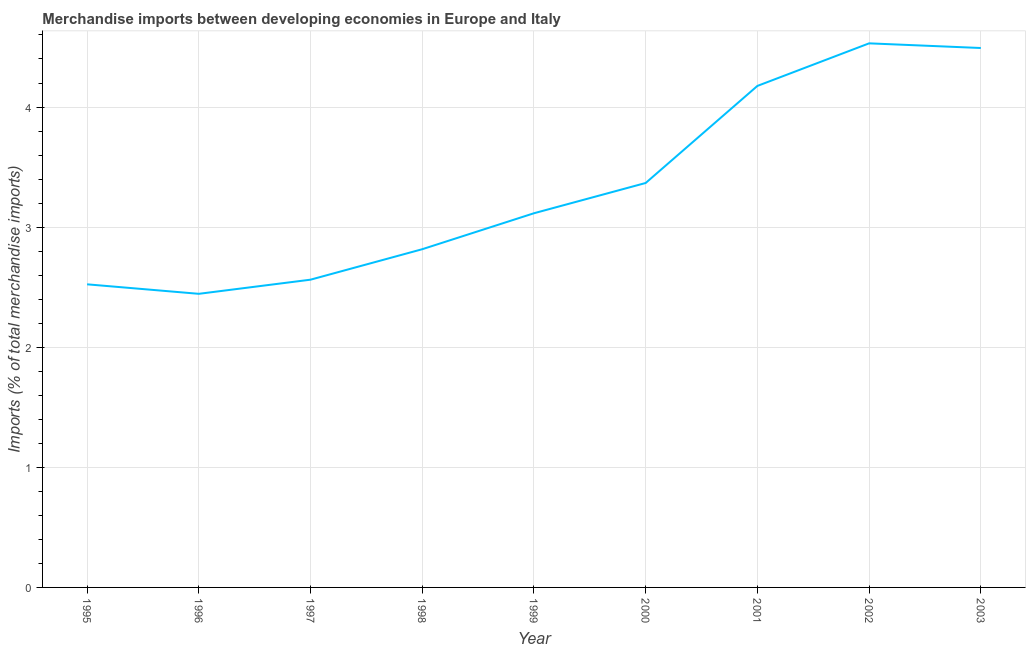What is the merchandise imports in 1995?
Keep it short and to the point. 2.52. Across all years, what is the maximum merchandise imports?
Your answer should be very brief. 4.53. Across all years, what is the minimum merchandise imports?
Your answer should be very brief. 2.44. What is the sum of the merchandise imports?
Your answer should be very brief. 30.03. What is the difference between the merchandise imports in 1999 and 2002?
Your answer should be very brief. -1.41. What is the average merchandise imports per year?
Provide a short and direct response. 3.34. What is the median merchandise imports?
Give a very brief answer. 3.12. Do a majority of the years between 1998 and 2000 (inclusive) have merchandise imports greater than 3.2 %?
Give a very brief answer. No. What is the ratio of the merchandise imports in 1997 to that in 2002?
Your response must be concise. 0.57. Is the merchandise imports in 1998 less than that in 2002?
Provide a succinct answer. Yes. What is the difference between the highest and the second highest merchandise imports?
Provide a short and direct response. 0.04. Is the sum of the merchandise imports in 1996 and 2003 greater than the maximum merchandise imports across all years?
Offer a very short reply. Yes. What is the difference between the highest and the lowest merchandise imports?
Your answer should be compact. 2.09. Does the merchandise imports monotonically increase over the years?
Your answer should be very brief. No. How many years are there in the graph?
Give a very brief answer. 9. What is the difference between two consecutive major ticks on the Y-axis?
Your answer should be very brief. 1. Are the values on the major ticks of Y-axis written in scientific E-notation?
Give a very brief answer. No. What is the title of the graph?
Make the answer very short. Merchandise imports between developing economies in Europe and Italy. What is the label or title of the Y-axis?
Make the answer very short. Imports (% of total merchandise imports). What is the Imports (% of total merchandise imports) of 1995?
Ensure brevity in your answer.  2.52. What is the Imports (% of total merchandise imports) in 1996?
Make the answer very short. 2.44. What is the Imports (% of total merchandise imports) in 1997?
Provide a short and direct response. 2.56. What is the Imports (% of total merchandise imports) in 1998?
Make the answer very short. 2.82. What is the Imports (% of total merchandise imports) of 1999?
Keep it short and to the point. 3.12. What is the Imports (% of total merchandise imports) in 2000?
Give a very brief answer. 3.37. What is the Imports (% of total merchandise imports) in 2001?
Provide a short and direct response. 4.18. What is the Imports (% of total merchandise imports) of 2002?
Give a very brief answer. 4.53. What is the Imports (% of total merchandise imports) in 2003?
Offer a terse response. 4.49. What is the difference between the Imports (% of total merchandise imports) in 1995 and 1996?
Ensure brevity in your answer.  0.08. What is the difference between the Imports (% of total merchandise imports) in 1995 and 1997?
Offer a terse response. -0.04. What is the difference between the Imports (% of total merchandise imports) in 1995 and 1998?
Keep it short and to the point. -0.29. What is the difference between the Imports (% of total merchandise imports) in 1995 and 1999?
Your response must be concise. -0.59. What is the difference between the Imports (% of total merchandise imports) in 1995 and 2000?
Keep it short and to the point. -0.84. What is the difference between the Imports (% of total merchandise imports) in 1995 and 2001?
Your answer should be very brief. -1.65. What is the difference between the Imports (% of total merchandise imports) in 1995 and 2002?
Make the answer very short. -2.01. What is the difference between the Imports (% of total merchandise imports) in 1995 and 2003?
Make the answer very short. -1.97. What is the difference between the Imports (% of total merchandise imports) in 1996 and 1997?
Your answer should be very brief. -0.12. What is the difference between the Imports (% of total merchandise imports) in 1996 and 1998?
Keep it short and to the point. -0.37. What is the difference between the Imports (% of total merchandise imports) in 1996 and 1999?
Offer a terse response. -0.67. What is the difference between the Imports (% of total merchandise imports) in 1996 and 2000?
Provide a succinct answer. -0.92. What is the difference between the Imports (% of total merchandise imports) in 1996 and 2001?
Give a very brief answer. -1.73. What is the difference between the Imports (% of total merchandise imports) in 1996 and 2002?
Provide a short and direct response. -2.09. What is the difference between the Imports (% of total merchandise imports) in 1996 and 2003?
Offer a terse response. -2.05. What is the difference between the Imports (% of total merchandise imports) in 1997 and 1998?
Keep it short and to the point. -0.25. What is the difference between the Imports (% of total merchandise imports) in 1997 and 1999?
Give a very brief answer. -0.55. What is the difference between the Imports (% of total merchandise imports) in 1997 and 2000?
Ensure brevity in your answer.  -0.81. What is the difference between the Imports (% of total merchandise imports) in 1997 and 2001?
Offer a very short reply. -1.61. What is the difference between the Imports (% of total merchandise imports) in 1997 and 2002?
Make the answer very short. -1.97. What is the difference between the Imports (% of total merchandise imports) in 1997 and 2003?
Give a very brief answer. -1.93. What is the difference between the Imports (% of total merchandise imports) in 1998 and 1999?
Offer a terse response. -0.3. What is the difference between the Imports (% of total merchandise imports) in 1998 and 2000?
Ensure brevity in your answer.  -0.55. What is the difference between the Imports (% of total merchandise imports) in 1998 and 2001?
Make the answer very short. -1.36. What is the difference between the Imports (% of total merchandise imports) in 1998 and 2002?
Make the answer very short. -1.71. What is the difference between the Imports (% of total merchandise imports) in 1998 and 2003?
Ensure brevity in your answer.  -1.68. What is the difference between the Imports (% of total merchandise imports) in 1999 and 2000?
Your response must be concise. -0.25. What is the difference between the Imports (% of total merchandise imports) in 1999 and 2001?
Keep it short and to the point. -1.06. What is the difference between the Imports (% of total merchandise imports) in 1999 and 2002?
Provide a succinct answer. -1.41. What is the difference between the Imports (% of total merchandise imports) in 1999 and 2003?
Your answer should be very brief. -1.38. What is the difference between the Imports (% of total merchandise imports) in 2000 and 2001?
Provide a succinct answer. -0.81. What is the difference between the Imports (% of total merchandise imports) in 2000 and 2002?
Provide a succinct answer. -1.16. What is the difference between the Imports (% of total merchandise imports) in 2000 and 2003?
Offer a terse response. -1.12. What is the difference between the Imports (% of total merchandise imports) in 2001 and 2002?
Keep it short and to the point. -0.35. What is the difference between the Imports (% of total merchandise imports) in 2001 and 2003?
Your answer should be compact. -0.32. What is the difference between the Imports (% of total merchandise imports) in 2002 and 2003?
Keep it short and to the point. 0.04. What is the ratio of the Imports (% of total merchandise imports) in 1995 to that in 1996?
Make the answer very short. 1.03. What is the ratio of the Imports (% of total merchandise imports) in 1995 to that in 1997?
Ensure brevity in your answer.  0.98. What is the ratio of the Imports (% of total merchandise imports) in 1995 to that in 1998?
Keep it short and to the point. 0.9. What is the ratio of the Imports (% of total merchandise imports) in 1995 to that in 1999?
Your response must be concise. 0.81. What is the ratio of the Imports (% of total merchandise imports) in 1995 to that in 2000?
Your response must be concise. 0.75. What is the ratio of the Imports (% of total merchandise imports) in 1995 to that in 2001?
Provide a succinct answer. 0.6. What is the ratio of the Imports (% of total merchandise imports) in 1995 to that in 2002?
Your response must be concise. 0.56. What is the ratio of the Imports (% of total merchandise imports) in 1995 to that in 2003?
Your answer should be compact. 0.56. What is the ratio of the Imports (% of total merchandise imports) in 1996 to that in 1997?
Ensure brevity in your answer.  0.95. What is the ratio of the Imports (% of total merchandise imports) in 1996 to that in 1998?
Make the answer very short. 0.87. What is the ratio of the Imports (% of total merchandise imports) in 1996 to that in 1999?
Ensure brevity in your answer.  0.79. What is the ratio of the Imports (% of total merchandise imports) in 1996 to that in 2000?
Give a very brief answer. 0.73. What is the ratio of the Imports (% of total merchandise imports) in 1996 to that in 2001?
Offer a terse response. 0.58. What is the ratio of the Imports (% of total merchandise imports) in 1996 to that in 2002?
Offer a very short reply. 0.54. What is the ratio of the Imports (% of total merchandise imports) in 1996 to that in 2003?
Offer a terse response. 0.54. What is the ratio of the Imports (% of total merchandise imports) in 1997 to that in 1998?
Your answer should be compact. 0.91. What is the ratio of the Imports (% of total merchandise imports) in 1997 to that in 1999?
Keep it short and to the point. 0.82. What is the ratio of the Imports (% of total merchandise imports) in 1997 to that in 2000?
Give a very brief answer. 0.76. What is the ratio of the Imports (% of total merchandise imports) in 1997 to that in 2001?
Ensure brevity in your answer.  0.61. What is the ratio of the Imports (% of total merchandise imports) in 1997 to that in 2002?
Keep it short and to the point. 0.57. What is the ratio of the Imports (% of total merchandise imports) in 1997 to that in 2003?
Give a very brief answer. 0.57. What is the ratio of the Imports (% of total merchandise imports) in 1998 to that in 1999?
Your response must be concise. 0.9. What is the ratio of the Imports (% of total merchandise imports) in 1998 to that in 2000?
Your answer should be compact. 0.84. What is the ratio of the Imports (% of total merchandise imports) in 1998 to that in 2001?
Keep it short and to the point. 0.67. What is the ratio of the Imports (% of total merchandise imports) in 1998 to that in 2002?
Your response must be concise. 0.62. What is the ratio of the Imports (% of total merchandise imports) in 1998 to that in 2003?
Give a very brief answer. 0.63. What is the ratio of the Imports (% of total merchandise imports) in 1999 to that in 2000?
Provide a short and direct response. 0.93. What is the ratio of the Imports (% of total merchandise imports) in 1999 to that in 2001?
Your response must be concise. 0.75. What is the ratio of the Imports (% of total merchandise imports) in 1999 to that in 2002?
Offer a very short reply. 0.69. What is the ratio of the Imports (% of total merchandise imports) in 1999 to that in 2003?
Offer a terse response. 0.69. What is the ratio of the Imports (% of total merchandise imports) in 2000 to that in 2001?
Keep it short and to the point. 0.81. What is the ratio of the Imports (% of total merchandise imports) in 2000 to that in 2002?
Keep it short and to the point. 0.74. What is the ratio of the Imports (% of total merchandise imports) in 2001 to that in 2002?
Offer a very short reply. 0.92. 